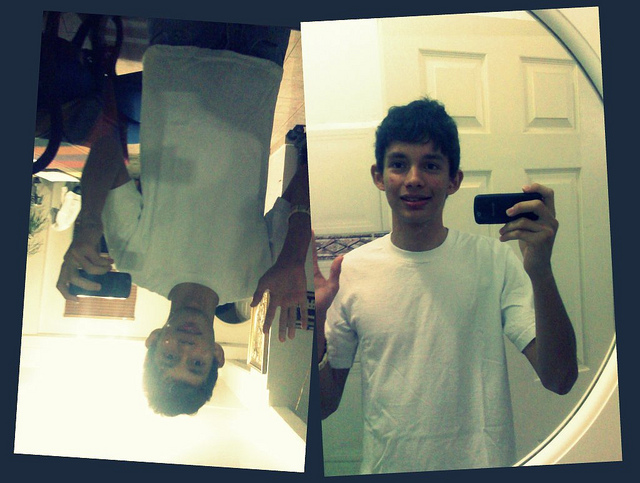Are there any objects or items in the background? In the background, there is a door with panels. The mirror reflects parts of the room; however, there aren't any distinct objects aside from the person and the phone that are clearly identifiable. 